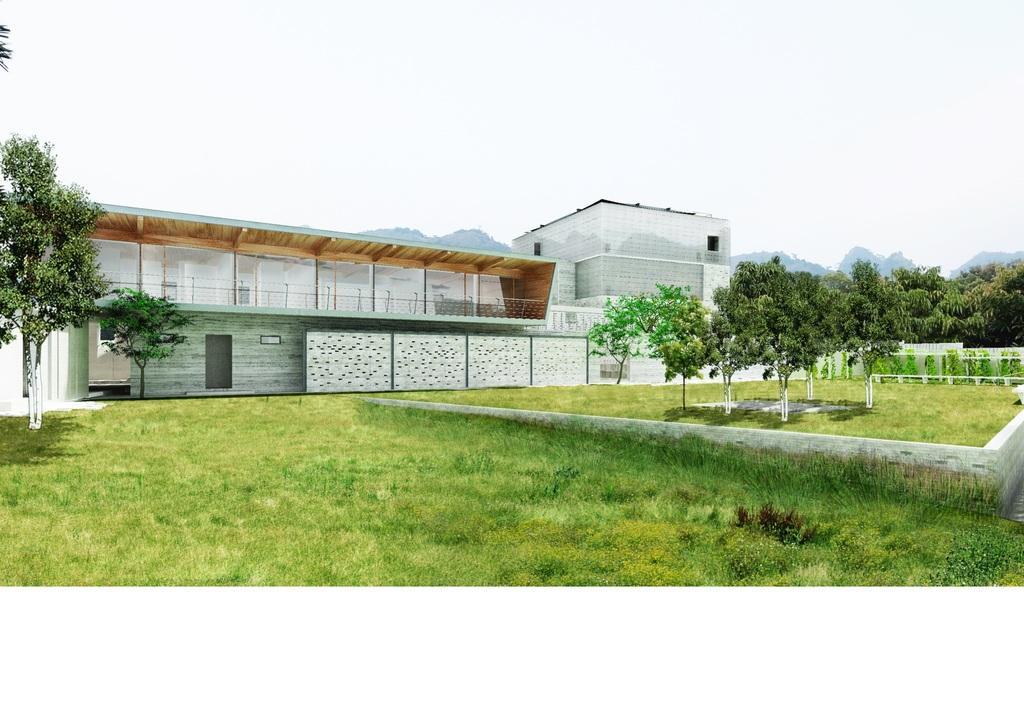Can you describe this image briefly? In this image, we can see a building which is colored white. There are trees on the left and on the right side of the image. There is a grass on the ground which at the bottom of the image. There is a sky at the top of the image. 